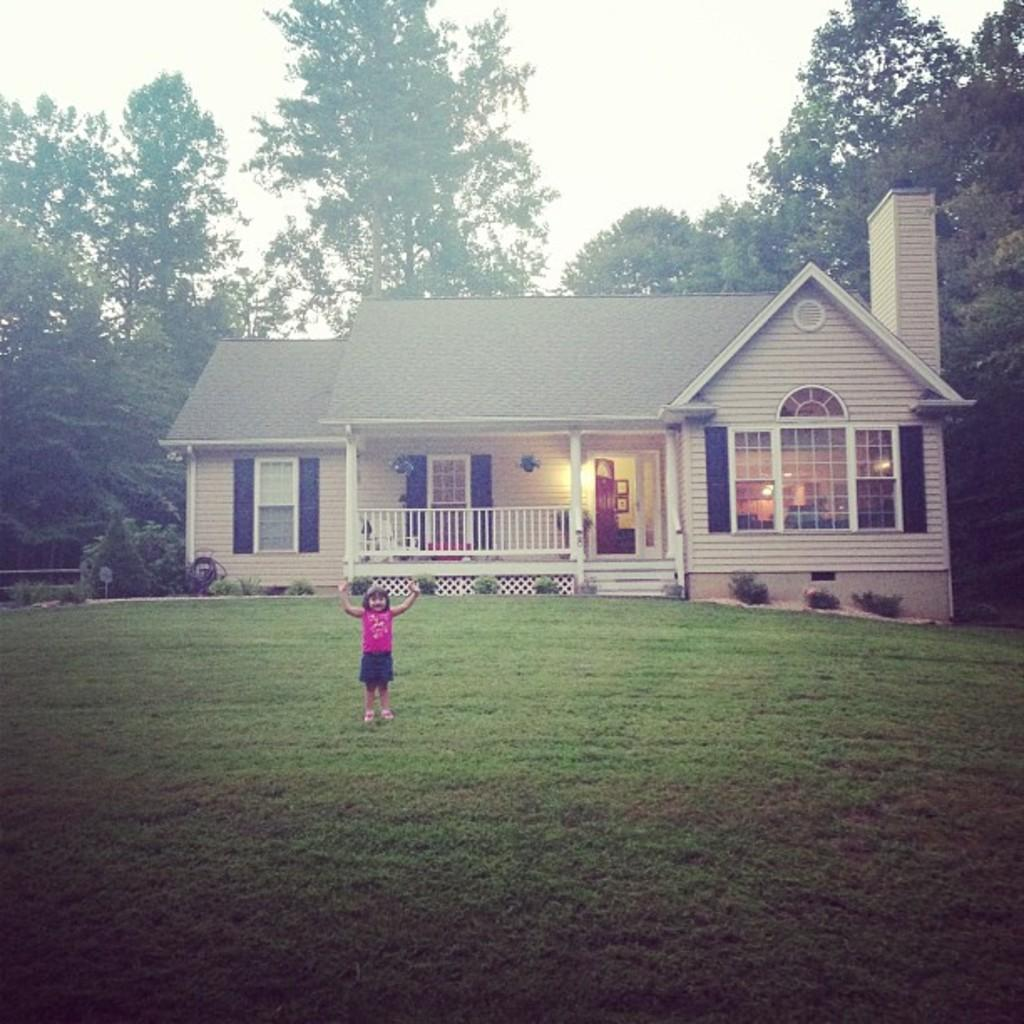What is the main subject of the image? There is a girl standing in the image. Where is the girl standing? The girl is standing on the ground. What structure is visible in the image? There is a house in the image. What features can be seen on the house? The house has windows and a door. What type of vegetation is present in the image? There are trees in the image. What can be seen in the background of the image? The sky is visible in the background of the image. What type of seed can be seen growing near the girl in the image? There is no seed visible in the image. 